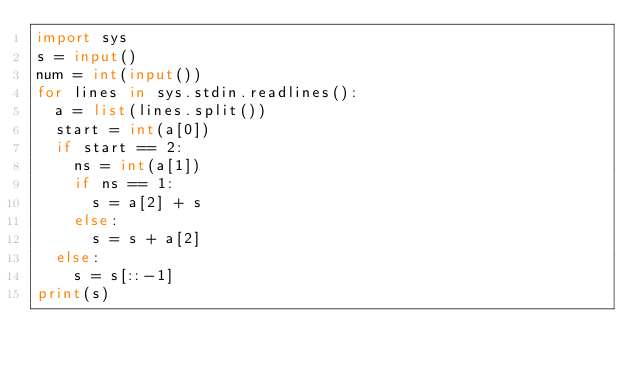<code> <loc_0><loc_0><loc_500><loc_500><_Python_>import sys
s = input()
num = int(input())
for lines in sys.stdin.readlines():
  a = list(lines.split())
  start = int(a[0])
  if start == 2:
    ns = int(a[1])
    if ns == 1:
      s = a[2] + s
    else:
      s = s + a[2]
  else:
    s = s[::-1]
print(s)</code> 